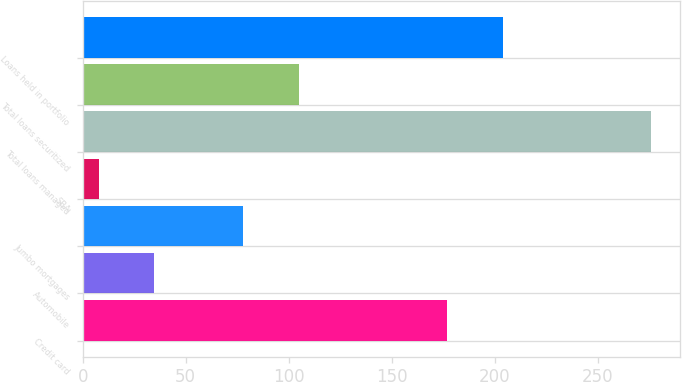Convert chart. <chart><loc_0><loc_0><loc_500><loc_500><bar_chart><fcel>Credit card<fcel>Automobile<fcel>Jumbo mortgages<fcel>SBA<fcel>Total loans managed<fcel>Total loans securitized<fcel>Loans held in portfolio<nl><fcel>177<fcel>34.8<fcel>78<fcel>8<fcel>276<fcel>104.8<fcel>203.8<nl></chart> 